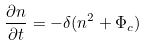Convert formula to latex. <formula><loc_0><loc_0><loc_500><loc_500>\frac { \partial n } { \partial t } = - \delta ( n ^ { 2 } + \Phi _ { c } )</formula> 